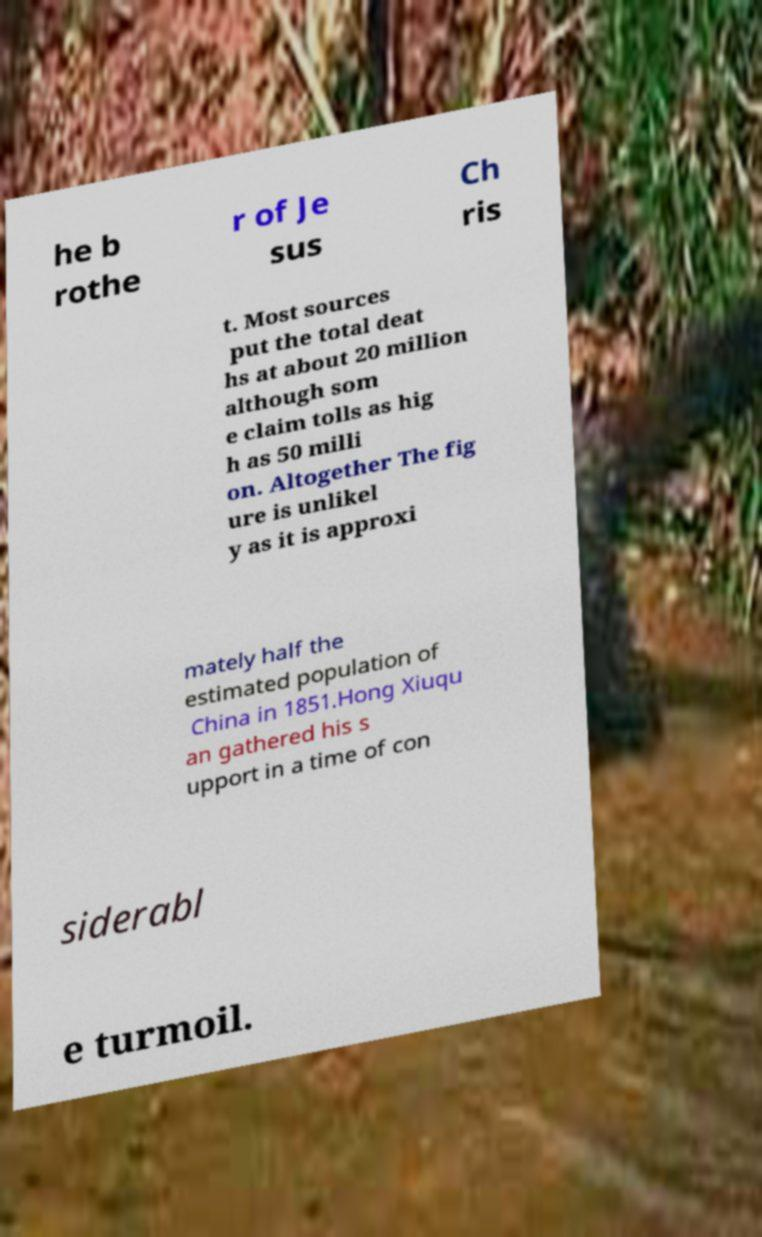For documentation purposes, I need the text within this image transcribed. Could you provide that? he b rothe r of Je sus Ch ris t. Most sources put the total deat hs at about 20 million although som e claim tolls as hig h as 50 milli on. Altogether The fig ure is unlikel y as it is approxi mately half the estimated population of China in 1851.Hong Xiuqu an gathered his s upport in a time of con siderabl e turmoil. 